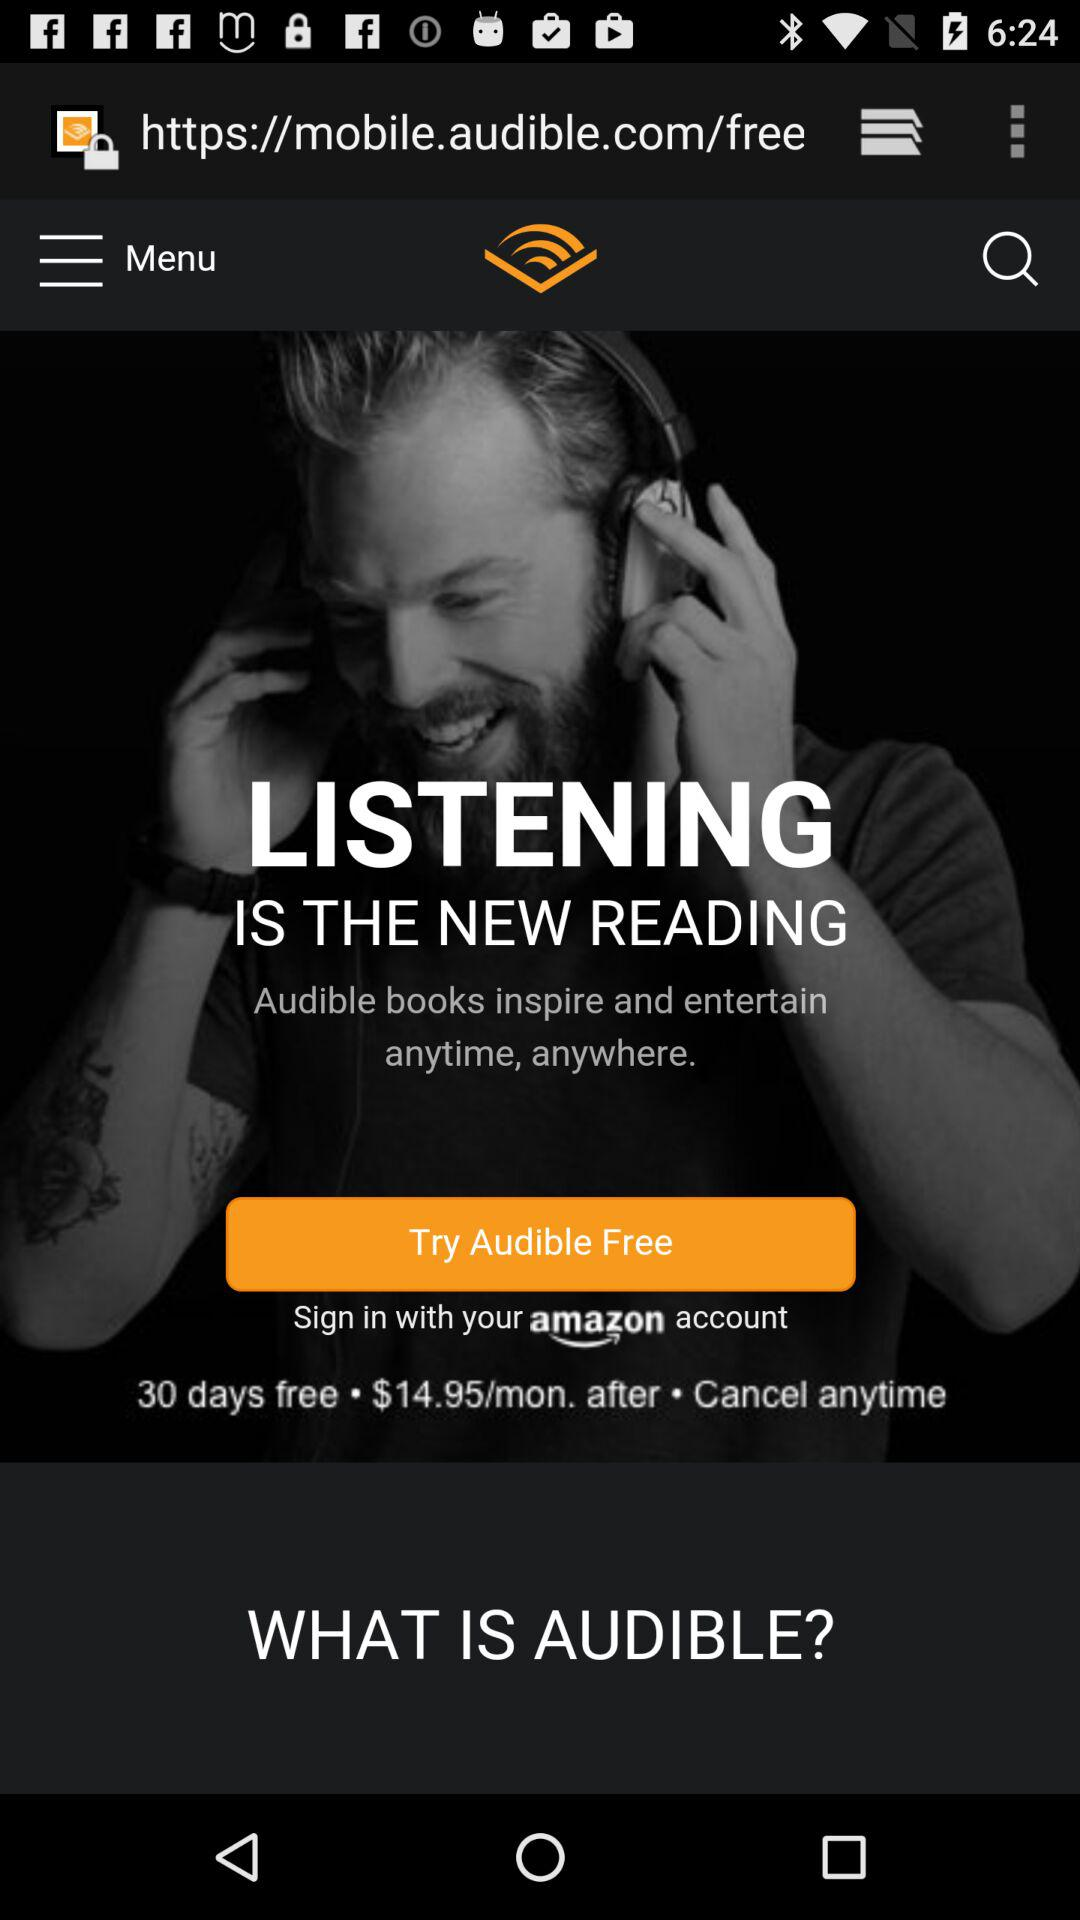How many days is the trial free? The trial is free for 30 days. 